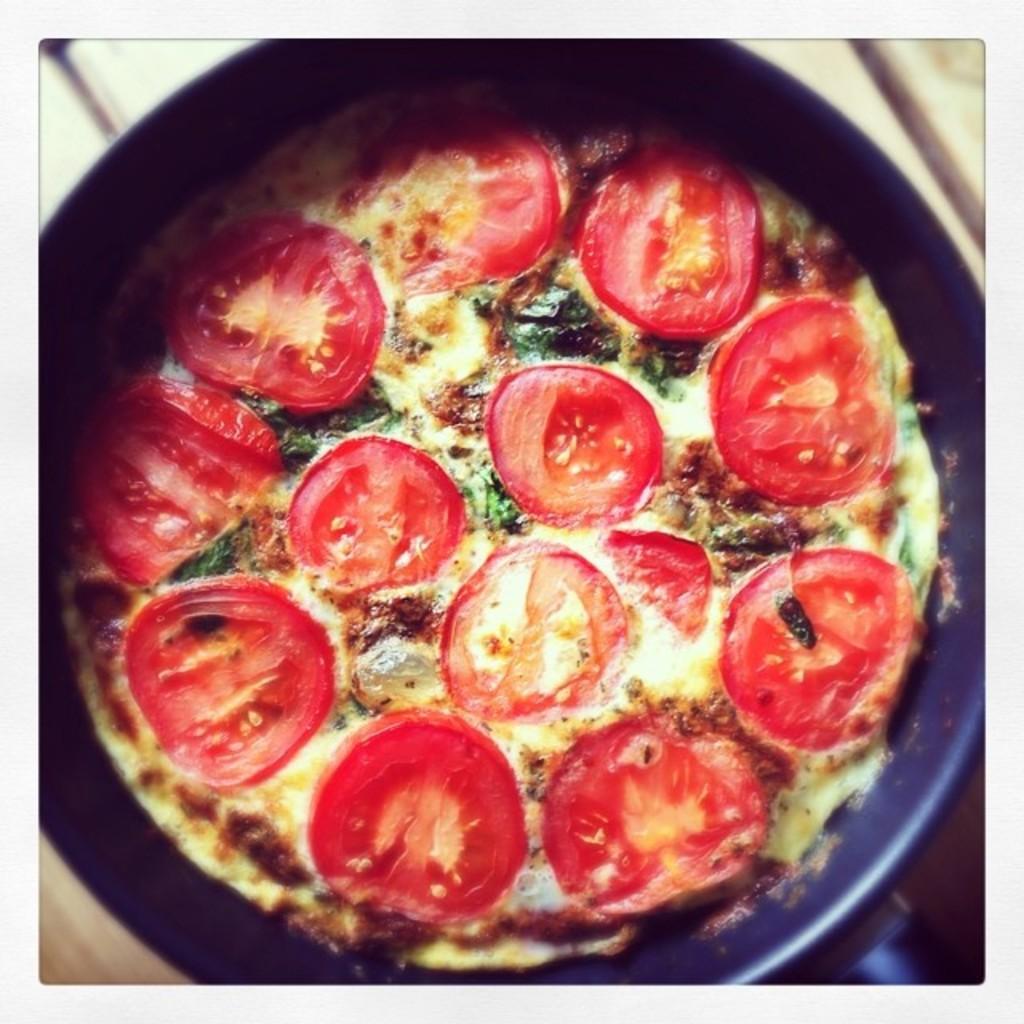Please provide a concise description of this image. In this image there is a bowl, in that bowl there is a food item, in the background it is blurred. 